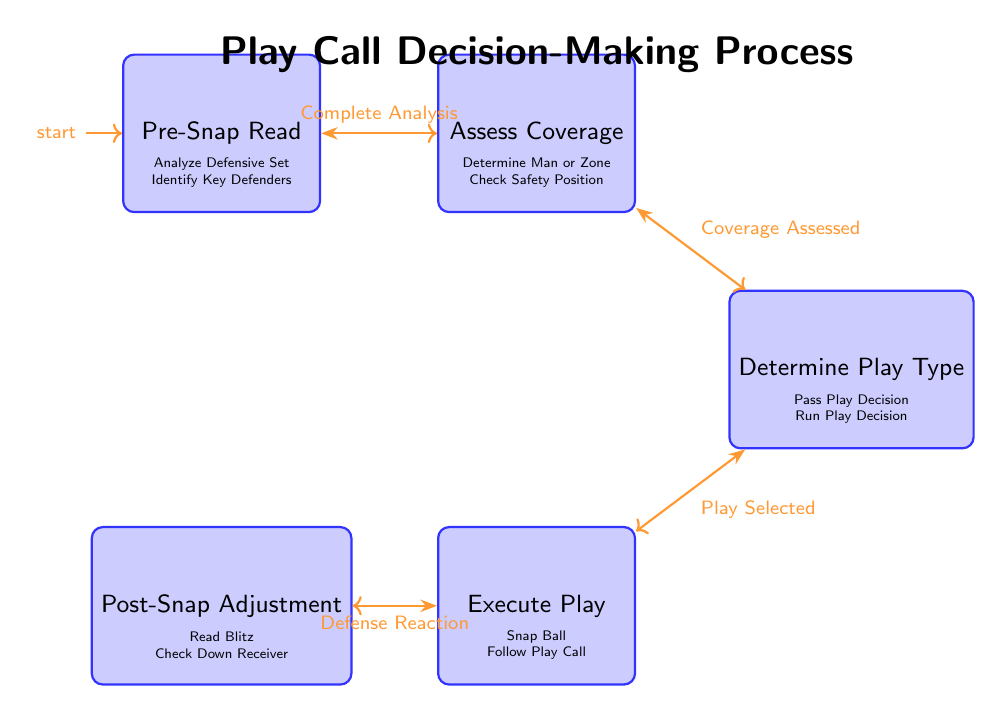What is the starting state of the diagram? The initial state of the finite state machine diagram is labeled "Pre-Snap Read". This is indicated by the "initial" node marker at the Pre-Snap Read state.
Answer: Pre-Snap Read How many states are in the diagram? The diagram contains five distinct states: Pre-Snap Read, Assess Coverage, Determine Play Type, Execute Play, and Post-Snap Adjustment. This can be counted by listing each state within the states section.
Answer: 5 What action is associated with the "Assess Coverage" state? The actions listed under the "Assess Coverage" state include "Determine Man or Zone" and "Check Safety Position". These actions are displayed directly beneath the Assess Coverage state node.
Answer: Determine Man or Zone; Check Safety Position What is the condition for transitioning from "Execute Play" to "Post-Snap Adjustment"? The transition from the "Execute Play" state to "Post-Snap Adjustment" is conditioned upon "Defense Reaction". This condition is specified in the labeled edge connecting these two states.
Answer: Defense Reaction Which state follows "Assess Coverage"? The state that follows "Assess Coverage" in the diagram is "Determine Play Type". This is clear from the transition connection from Assess Coverage to Determine Play Type marked with the condition "Coverage Assessed".
Answer: Determine Play Type What does "Post-Snap Adjustment" primarily involve? The state "Post-Snap Adjustment" primarily involves reading the defense's response. The actions specified below this state are "Read Blitz" and "Check Down Receiver", indicating the focus of adjustments made post-snap.
Answer: Read Blitz; Check Down Receiver If the coverage is assessed, what state will the process transition to next? Upon assessing the coverage, the process will transition to the "Determine Play Type" state. This is determined by the transition condition labeled as "Coverage Assessed", directly linking these two states.
Answer: Determine Play Type What action occurs in the last state of the diagram? The last state "Post-Snap Adjustment" encompasses actions related to evaluating the defense after the play is executed. The specific actions are "Read Blitz" and "Check Down Receiver".
Answer: Read Blitz; Check Down Receiver 